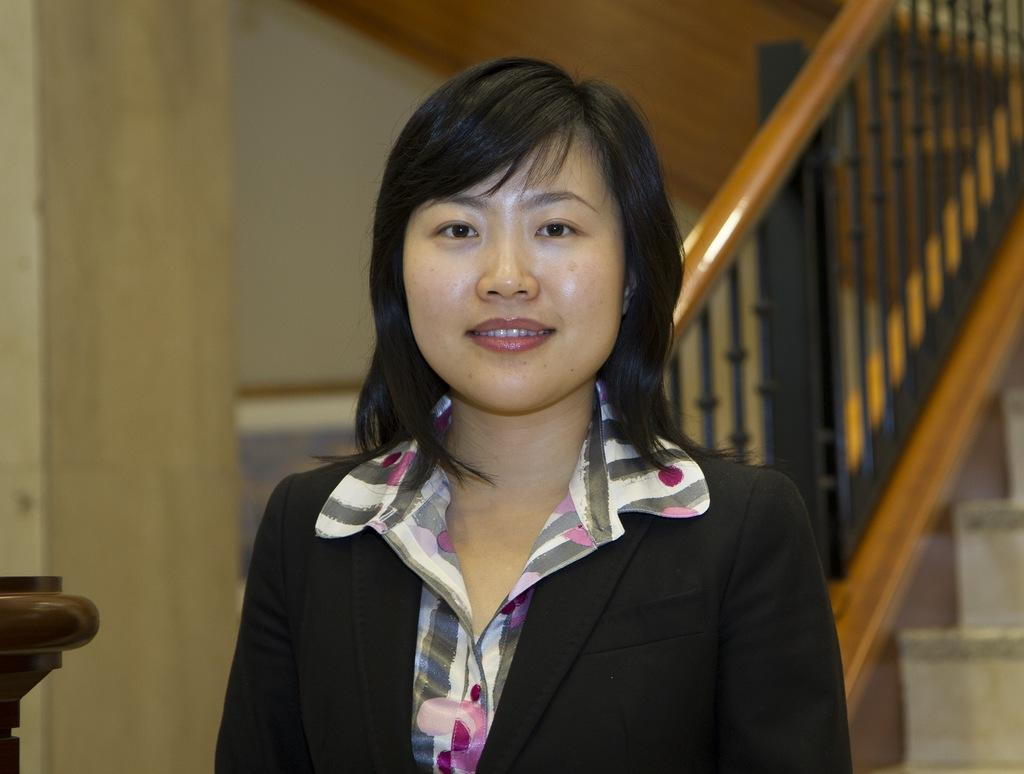Who is the main subject in the image? There is a woman in the image. Where is the woman located in the image? The woman is in the middle of the image. What is the woman wearing in the image? The woman is wearing a coat in the image. What architectural feature can be seen on the right side of the image? There is a staircase on the right side of the image. What type of impulse can be seen affecting the woman in the image? There is no impulse affecting the woman in the image; she appears to be standing still. 